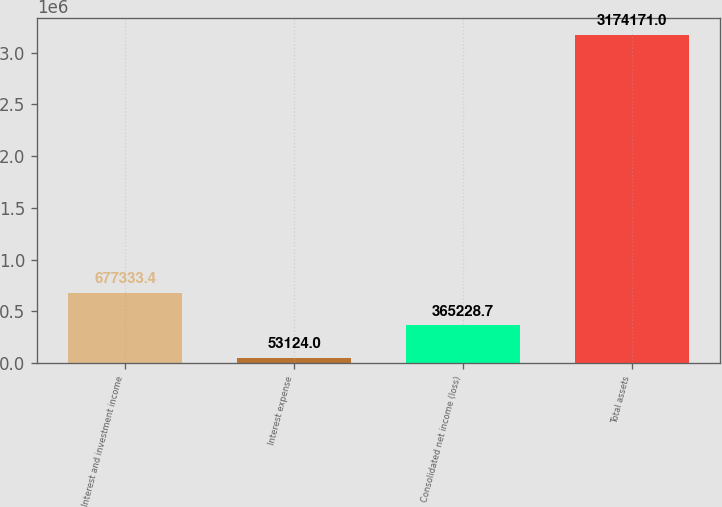<chart> <loc_0><loc_0><loc_500><loc_500><bar_chart><fcel>Interest and investment income<fcel>Interest expense<fcel>Consolidated net income (loss)<fcel>Total assets<nl><fcel>677333<fcel>53124<fcel>365229<fcel>3.17417e+06<nl></chart> 